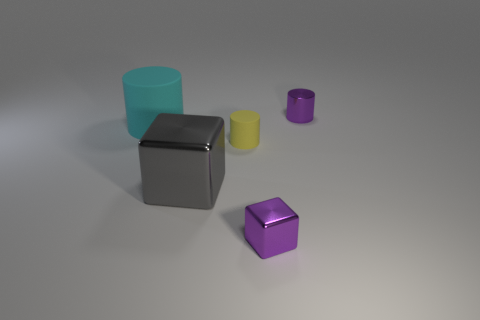Subtract all metal cylinders. How many cylinders are left? 2 Subtract 1 blocks. How many blocks are left? 1 Add 4 small metal cylinders. How many objects exist? 9 Subtract all gray blocks. How many blocks are left? 1 Subtract all cylinders. How many objects are left? 2 Subtract all yellow cubes. Subtract all brown cylinders. How many cubes are left? 2 Subtract all green metal cubes. Subtract all purple metallic cubes. How many objects are left? 4 Add 1 big cylinders. How many big cylinders are left? 2 Add 5 purple cylinders. How many purple cylinders exist? 6 Subtract 0 purple balls. How many objects are left? 5 